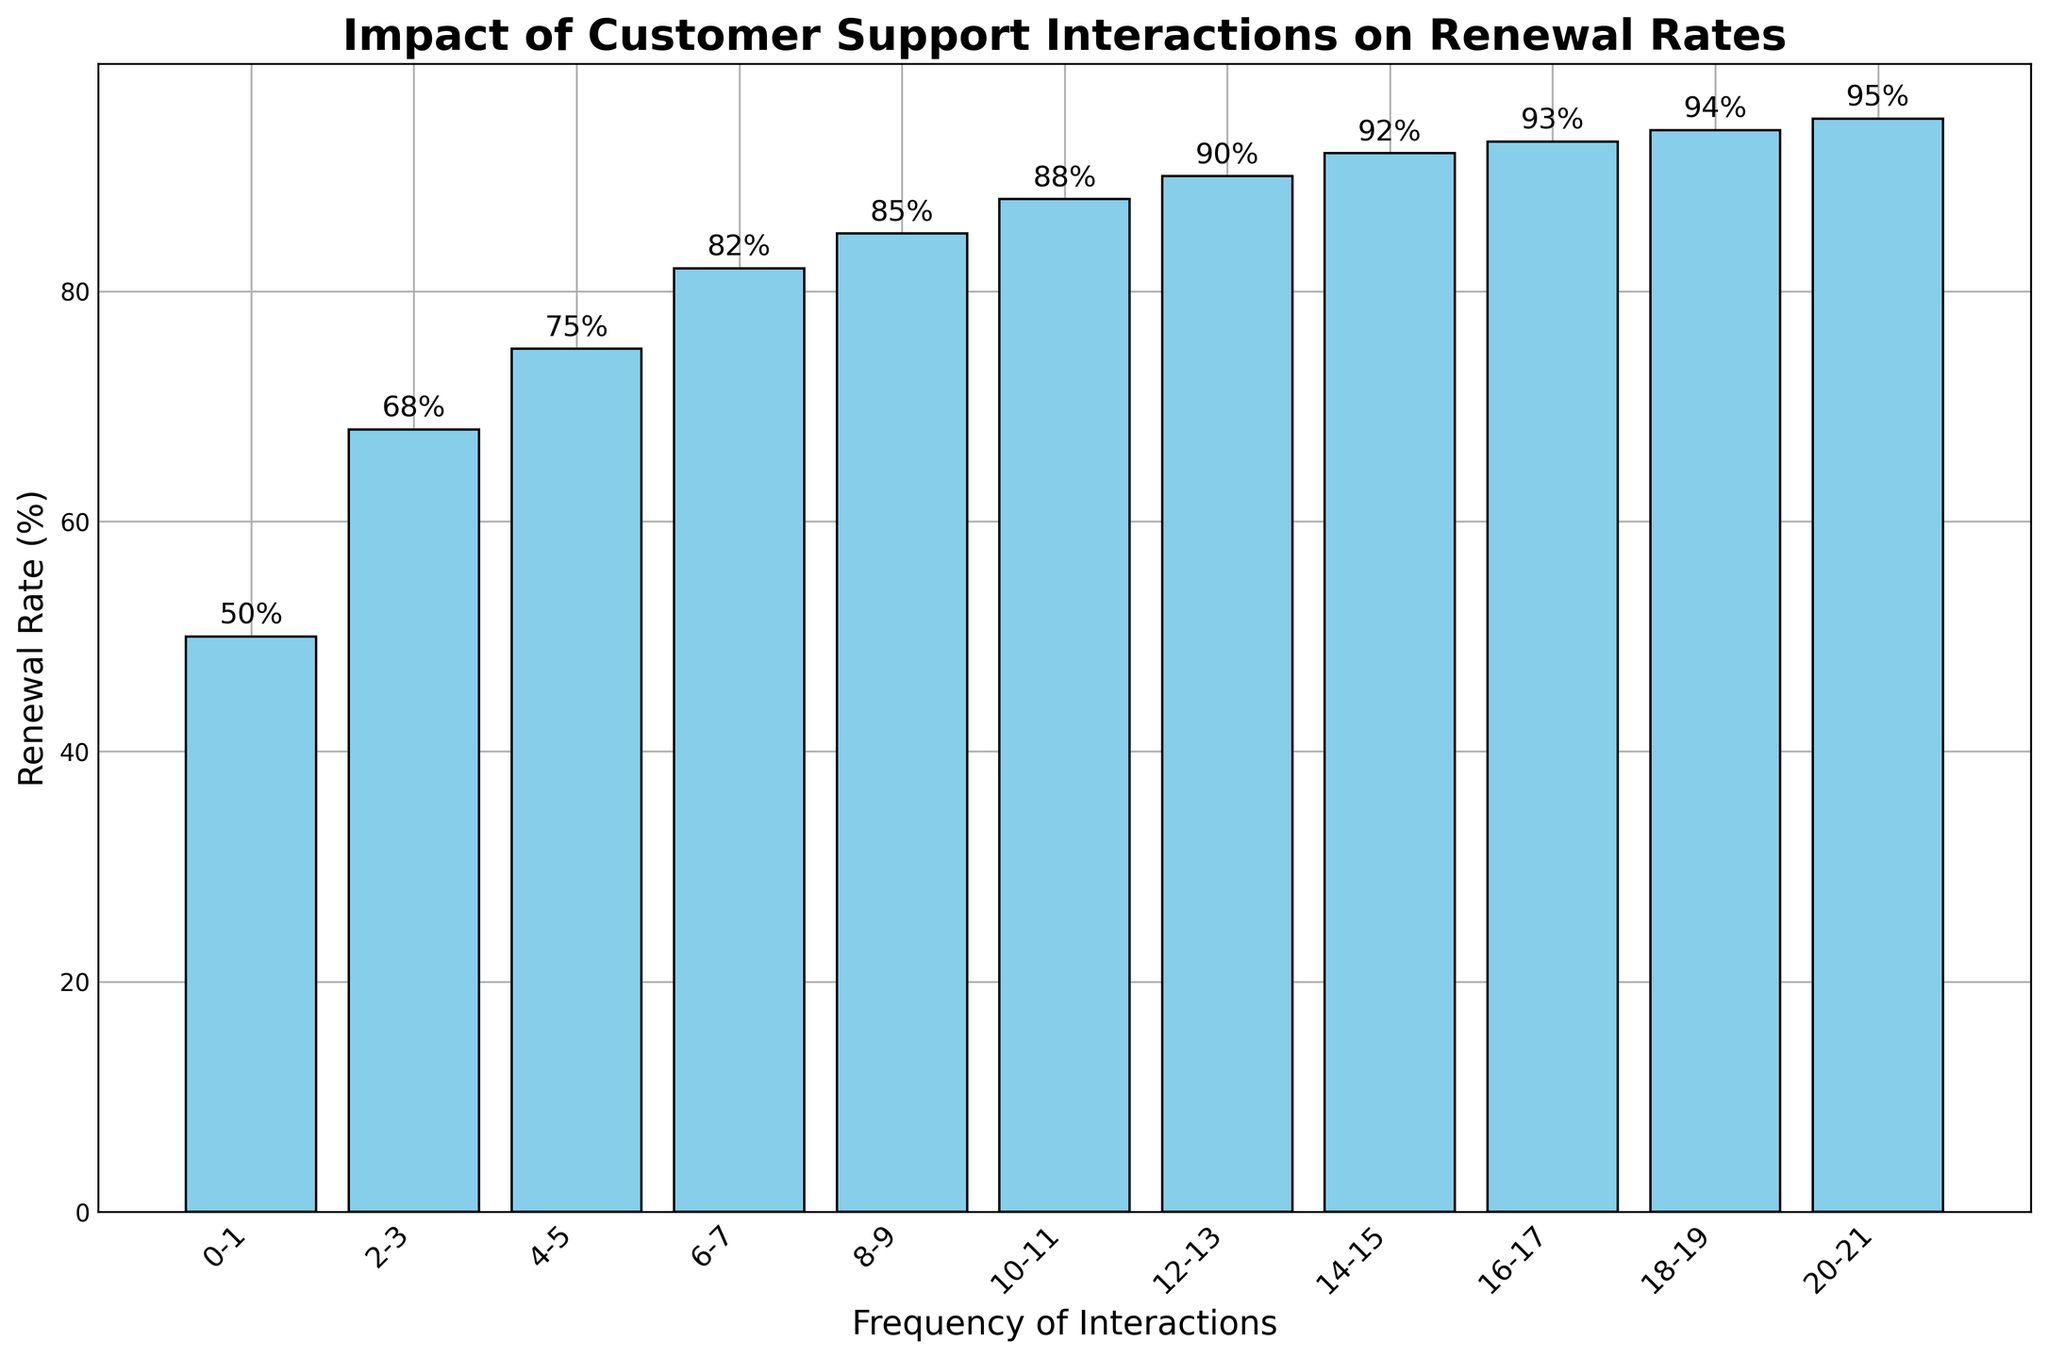How does the renewal rate change as the frequency of interactions increases? As we move from left to right on the x-axis, the height of the bars increases consistently. This indicates that the renewal rate goes up as the frequency of customer support interactions increases.
Answer: Renewal rate increases What is the renewal rate for customers with 4-5 interactions? Locate the bar labeled "4-5" on the x-axis and check its height. The height is annotated as 75%.
Answer: 75% Which frequency group has the highest renewal rate? Look for the tallest bar on the chart. The tallest bar corresponds to the "20-21" frequency group with a renewal rate of 95%.
Answer: 20-21 By how much does the renewal rate increase when moving from the "0-1" group to the "2-3" group? Subtract the renewal rate of the "0-1" group (50%) from the renewal rate of the "2-3" group (68%).
Answer: 18% Is there any frequency group where the renewal rate is below 60%? Check the heights of the bars and their annotations. The "0-1" group has a renewal rate of 50%, which is below 60%.
Answer: Yes, 0-1 What is the average renewal rate for the frequency groups "10-11" to "14-15"? Sum the renewal rates of "10-11" (88%), "12-13" (90%), and "14-15" (92%) and then divide by 3. (88+90+92)/3 = 90%
Answer: 90% How many percentage points higher is the renewal rate for the "16-17" group compared to the "8-9" group? Subtract the renewal rate of the "8-9" group (85%) from the renewal rate of the "16-17" group (93%).
Answer: 8 percentage points Do customers with more than 10 support interactions have a renewal rate of 90% or higher? Check the heights and annotations of bars for frequency groups from "10-11" onwards. All these groups have renewal rates of 90% or higher.
Answer: Yes Between which two consecutive frequency groups does the largest increase in renewal rate occur? Calculate the differences in renewal rates for consecutive groups. The largest increase is between "0-1" (50%) and "2-3" (68%), a difference of 18%.
Answer: 0-1 to 2-3 